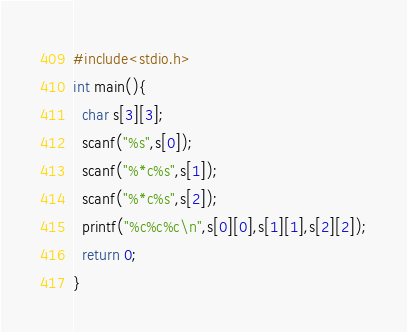Convert code to text. <code><loc_0><loc_0><loc_500><loc_500><_C_>#include<stdio.h>
int main(){
  char s[3][3];
  scanf("%s",s[0]);
  scanf("%*c%s",s[1]);
  scanf("%*c%s",s[2]);
  printf("%c%c%c\n",s[0][0],s[1][1],s[2][2]);
  return 0;
}
</code> 